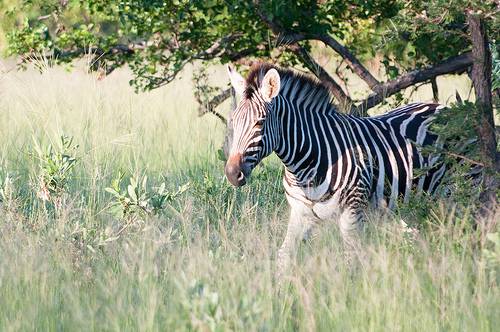Please provide the bounding box coordinate of the region this sentence describes: thin trunk of a tree. The bounding box coordinates for the thin trunk of the tree are [0.93, 0.19, 1.0, 0.58]. The coordinates indicate a region that likely encompasses the slender portion of the tree's trunk. 